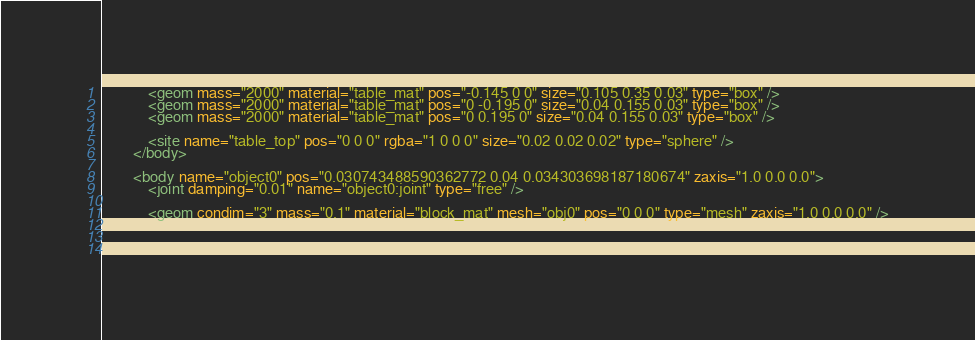<code> <loc_0><loc_0><loc_500><loc_500><_XML_>			<geom mass="2000" material="table_mat" pos="-0.145 0 0" size="0.105 0.35 0.03" type="box" />
			<geom mass="2000" material="table_mat" pos="0 -0.195 0" size="0.04 0.155 0.03" type="box" />
			<geom mass="2000" material="table_mat" pos="0 0.195 0" size="0.04 0.155 0.03" type="box" />

			<site name="table_top" pos="0 0 0" rgba="1 0 0 0" size="0.02 0.02 0.02" type="sphere" />
		</body>

		<body name="object0" pos="0.030743488590362772 0.04 0.034303698187180674" zaxis="1.0 0.0 0.0">
			<joint damping="0.01" name="object0:joint" type="free" />
			
			<geom condim="3" mass="0.1" material="block_mat" mesh="obj0" pos="0 0 0" type="mesh" zaxis="1.0 0.0 0.0" />
			
			
			</code> 